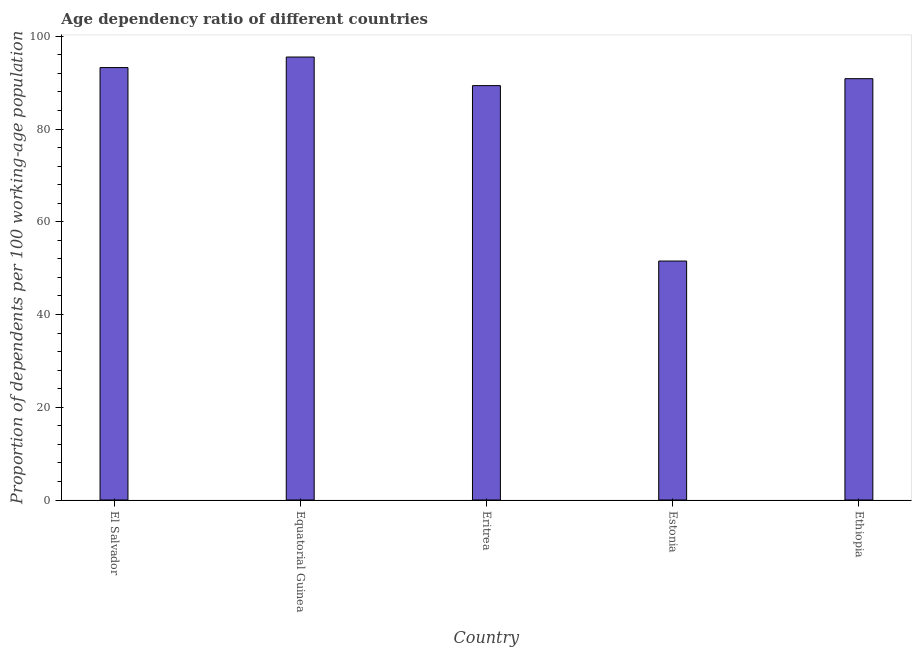Does the graph contain any zero values?
Ensure brevity in your answer.  No. What is the title of the graph?
Your answer should be compact. Age dependency ratio of different countries. What is the label or title of the Y-axis?
Keep it short and to the point. Proportion of dependents per 100 working-age population. What is the age dependency ratio in El Salvador?
Offer a very short reply. 93.26. Across all countries, what is the maximum age dependency ratio?
Make the answer very short. 95.54. Across all countries, what is the minimum age dependency ratio?
Give a very brief answer. 51.54. In which country was the age dependency ratio maximum?
Offer a terse response. Equatorial Guinea. In which country was the age dependency ratio minimum?
Offer a terse response. Estonia. What is the sum of the age dependency ratio?
Ensure brevity in your answer.  420.57. What is the difference between the age dependency ratio in El Salvador and Equatorial Guinea?
Keep it short and to the point. -2.27. What is the average age dependency ratio per country?
Keep it short and to the point. 84.11. What is the median age dependency ratio?
Ensure brevity in your answer.  90.87. In how many countries, is the age dependency ratio greater than 40 ?
Offer a terse response. 5. What is the ratio of the age dependency ratio in Equatorial Guinea to that in Estonia?
Ensure brevity in your answer.  1.85. What is the difference between the highest and the second highest age dependency ratio?
Provide a short and direct response. 2.27. Is the sum of the age dependency ratio in Equatorial Guinea and Eritrea greater than the maximum age dependency ratio across all countries?
Make the answer very short. Yes. What is the difference between the highest and the lowest age dependency ratio?
Give a very brief answer. 44. In how many countries, is the age dependency ratio greater than the average age dependency ratio taken over all countries?
Give a very brief answer. 4. Are all the bars in the graph horizontal?
Ensure brevity in your answer.  No. What is the difference between two consecutive major ticks on the Y-axis?
Your answer should be compact. 20. What is the Proportion of dependents per 100 working-age population in El Salvador?
Offer a very short reply. 93.26. What is the Proportion of dependents per 100 working-age population of Equatorial Guinea?
Your answer should be very brief. 95.54. What is the Proportion of dependents per 100 working-age population in Eritrea?
Your response must be concise. 89.37. What is the Proportion of dependents per 100 working-age population in Estonia?
Make the answer very short. 51.54. What is the Proportion of dependents per 100 working-age population of Ethiopia?
Offer a terse response. 90.87. What is the difference between the Proportion of dependents per 100 working-age population in El Salvador and Equatorial Guinea?
Keep it short and to the point. -2.27. What is the difference between the Proportion of dependents per 100 working-age population in El Salvador and Eritrea?
Make the answer very short. 3.89. What is the difference between the Proportion of dependents per 100 working-age population in El Salvador and Estonia?
Offer a very short reply. 41.72. What is the difference between the Proportion of dependents per 100 working-age population in El Salvador and Ethiopia?
Provide a short and direct response. 2.4. What is the difference between the Proportion of dependents per 100 working-age population in Equatorial Guinea and Eritrea?
Your response must be concise. 6.17. What is the difference between the Proportion of dependents per 100 working-age population in Equatorial Guinea and Estonia?
Your answer should be very brief. 44. What is the difference between the Proportion of dependents per 100 working-age population in Equatorial Guinea and Ethiopia?
Your answer should be very brief. 4.67. What is the difference between the Proportion of dependents per 100 working-age population in Eritrea and Estonia?
Make the answer very short. 37.83. What is the difference between the Proportion of dependents per 100 working-age population in Eritrea and Ethiopia?
Offer a very short reply. -1.5. What is the difference between the Proportion of dependents per 100 working-age population in Estonia and Ethiopia?
Provide a short and direct response. -39.33. What is the ratio of the Proportion of dependents per 100 working-age population in El Salvador to that in Eritrea?
Offer a terse response. 1.04. What is the ratio of the Proportion of dependents per 100 working-age population in El Salvador to that in Estonia?
Keep it short and to the point. 1.81. What is the ratio of the Proportion of dependents per 100 working-age population in El Salvador to that in Ethiopia?
Ensure brevity in your answer.  1.03. What is the ratio of the Proportion of dependents per 100 working-age population in Equatorial Guinea to that in Eritrea?
Provide a short and direct response. 1.07. What is the ratio of the Proportion of dependents per 100 working-age population in Equatorial Guinea to that in Estonia?
Make the answer very short. 1.85. What is the ratio of the Proportion of dependents per 100 working-age population in Equatorial Guinea to that in Ethiopia?
Offer a very short reply. 1.05. What is the ratio of the Proportion of dependents per 100 working-age population in Eritrea to that in Estonia?
Provide a short and direct response. 1.73. What is the ratio of the Proportion of dependents per 100 working-age population in Eritrea to that in Ethiopia?
Your answer should be compact. 0.98. What is the ratio of the Proportion of dependents per 100 working-age population in Estonia to that in Ethiopia?
Your answer should be compact. 0.57. 